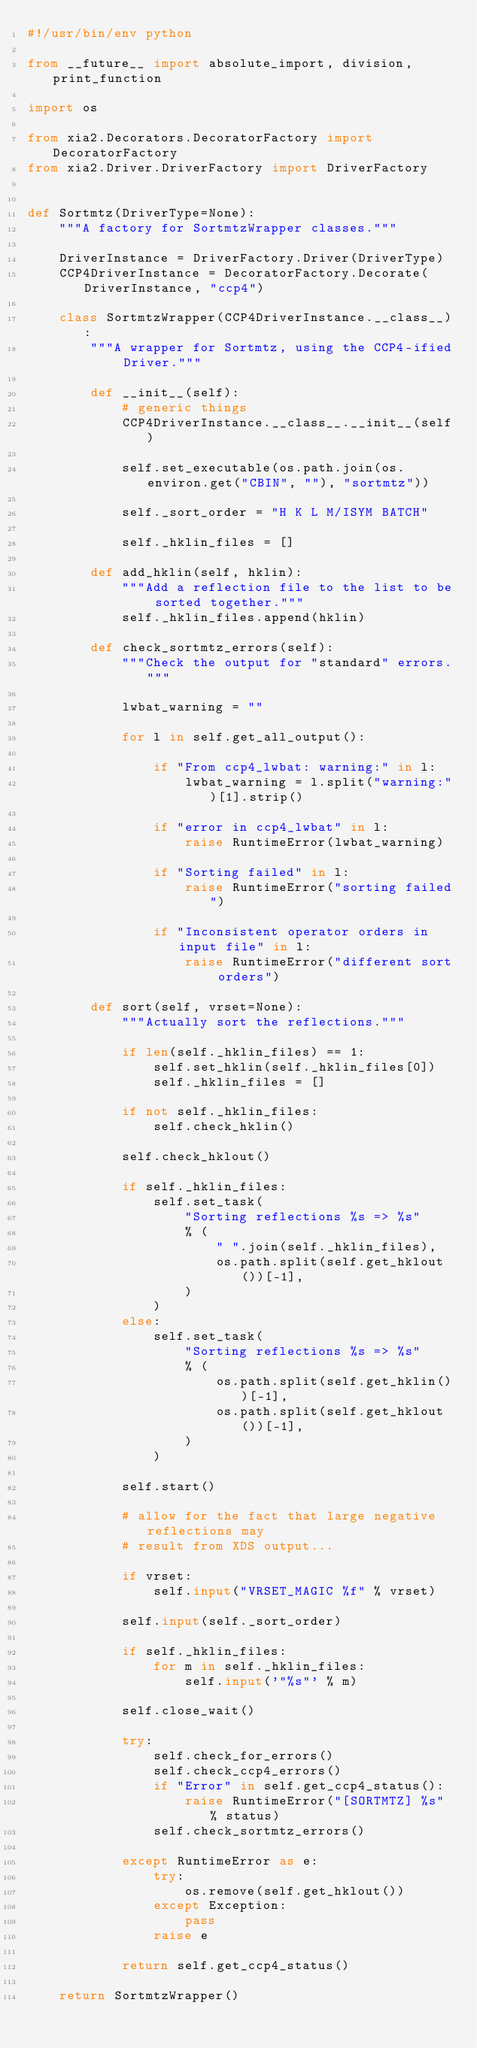<code> <loc_0><loc_0><loc_500><loc_500><_Python_>#!/usr/bin/env python

from __future__ import absolute_import, division, print_function

import os

from xia2.Decorators.DecoratorFactory import DecoratorFactory
from xia2.Driver.DriverFactory import DriverFactory


def Sortmtz(DriverType=None):
    """A factory for SortmtzWrapper classes."""

    DriverInstance = DriverFactory.Driver(DriverType)
    CCP4DriverInstance = DecoratorFactory.Decorate(DriverInstance, "ccp4")

    class SortmtzWrapper(CCP4DriverInstance.__class__):
        """A wrapper for Sortmtz, using the CCP4-ified Driver."""

        def __init__(self):
            # generic things
            CCP4DriverInstance.__class__.__init__(self)

            self.set_executable(os.path.join(os.environ.get("CBIN", ""), "sortmtz"))

            self._sort_order = "H K L M/ISYM BATCH"

            self._hklin_files = []

        def add_hklin(self, hklin):
            """Add a reflection file to the list to be sorted together."""
            self._hklin_files.append(hklin)

        def check_sortmtz_errors(self):
            """Check the output for "standard" errors."""

            lwbat_warning = ""

            for l in self.get_all_output():

                if "From ccp4_lwbat: warning:" in l:
                    lwbat_warning = l.split("warning:")[1].strip()

                if "error in ccp4_lwbat" in l:
                    raise RuntimeError(lwbat_warning)

                if "Sorting failed" in l:
                    raise RuntimeError("sorting failed")

                if "Inconsistent operator orders in input file" in l:
                    raise RuntimeError("different sort orders")

        def sort(self, vrset=None):
            """Actually sort the reflections."""

            if len(self._hklin_files) == 1:
                self.set_hklin(self._hklin_files[0])
                self._hklin_files = []

            if not self._hklin_files:
                self.check_hklin()

            self.check_hklout()

            if self._hklin_files:
                self.set_task(
                    "Sorting reflections %s => %s"
                    % (
                        " ".join(self._hklin_files),
                        os.path.split(self.get_hklout())[-1],
                    )
                )
            else:
                self.set_task(
                    "Sorting reflections %s => %s"
                    % (
                        os.path.split(self.get_hklin())[-1],
                        os.path.split(self.get_hklout())[-1],
                    )
                )

            self.start()

            # allow for the fact that large negative reflections may
            # result from XDS output...

            if vrset:
                self.input("VRSET_MAGIC %f" % vrset)

            self.input(self._sort_order)

            if self._hklin_files:
                for m in self._hklin_files:
                    self.input('"%s"' % m)

            self.close_wait()

            try:
                self.check_for_errors()
                self.check_ccp4_errors()
                if "Error" in self.get_ccp4_status():
                    raise RuntimeError("[SORTMTZ] %s" % status)
                self.check_sortmtz_errors()

            except RuntimeError as e:
                try:
                    os.remove(self.get_hklout())
                except Exception:
                    pass
                raise e

            return self.get_ccp4_status()

    return SortmtzWrapper()
</code> 